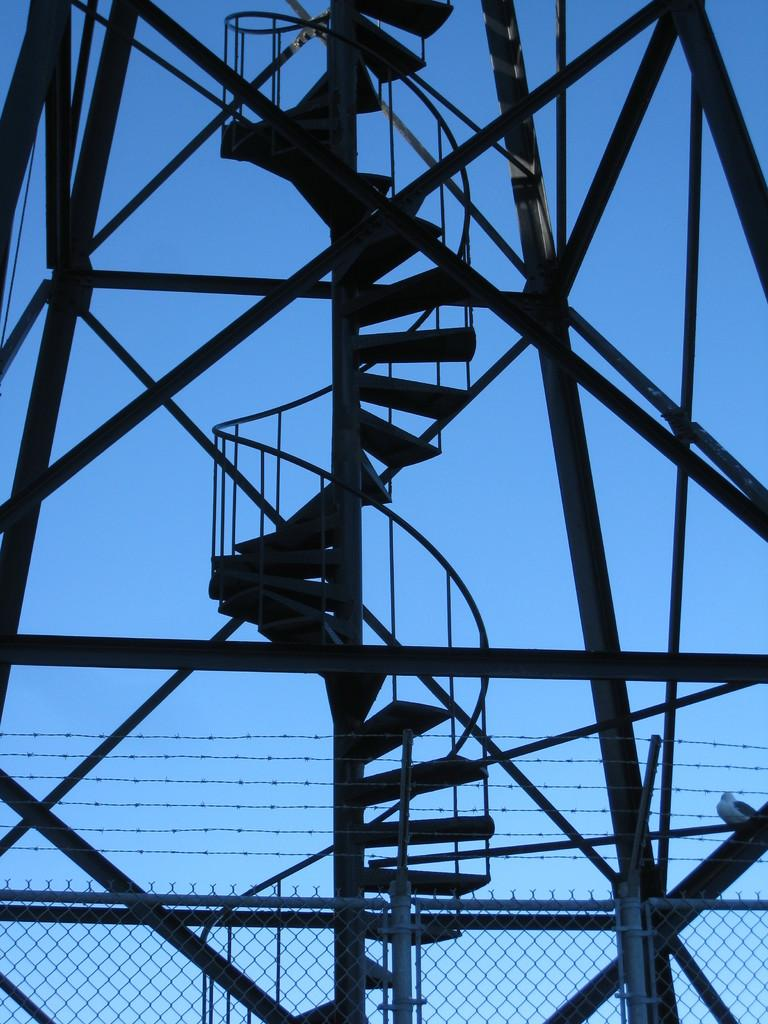What type of structure is visible in the image? There is a metal construction in the image. What architectural feature is present in the image? There are stairs in the image. What is located behind the metal construction? There is a fencing behind the metal construction. What type of material is used in the fencing? Metal grills are present in the fencing. What can be seen through the metal grills? The sky is visible through the metal grills. Can you tell me the name of the girl who is breaking the rule by walking the wrong way in the image? There is no girl present in the image, nor is there any indication of a rule being broken or a specific way to walk. 